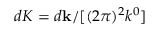Convert formula to latex. <formula><loc_0><loc_0><loc_500><loc_500>d K = d k / [ ( 2 \pi ) ^ { 2 } k ^ { 0 } ]</formula> 